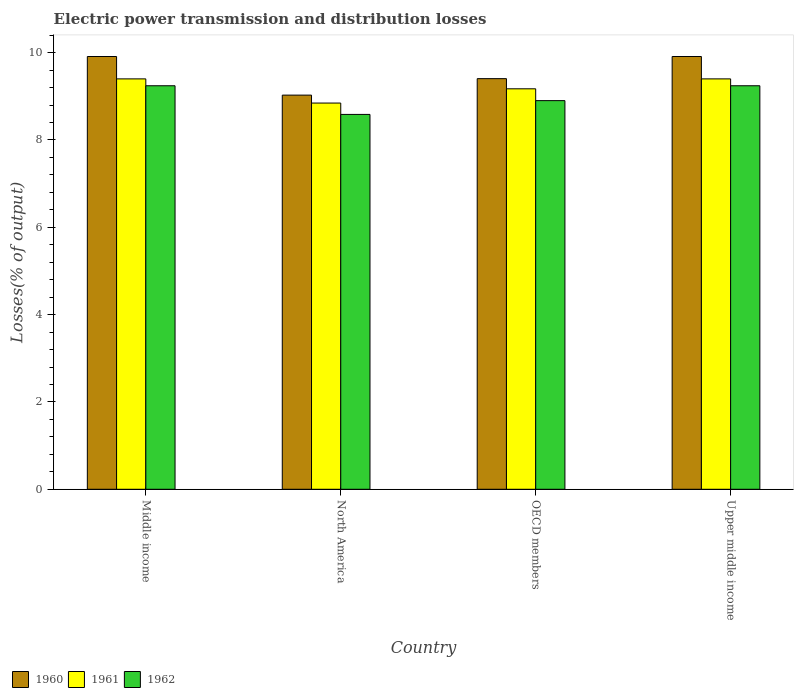How many different coloured bars are there?
Provide a short and direct response. 3. Are the number of bars per tick equal to the number of legend labels?
Make the answer very short. Yes. How many bars are there on the 2nd tick from the right?
Provide a succinct answer. 3. What is the label of the 2nd group of bars from the left?
Give a very brief answer. North America. What is the electric power transmission and distribution losses in 1962 in North America?
Give a very brief answer. 8.59. Across all countries, what is the maximum electric power transmission and distribution losses in 1962?
Your answer should be compact. 9.24. Across all countries, what is the minimum electric power transmission and distribution losses in 1961?
Your response must be concise. 8.85. What is the total electric power transmission and distribution losses in 1962 in the graph?
Keep it short and to the point. 35.97. What is the difference between the electric power transmission and distribution losses in 1961 in North America and that in Upper middle income?
Keep it short and to the point. -0.55. What is the difference between the electric power transmission and distribution losses in 1960 in North America and the electric power transmission and distribution losses in 1962 in Middle income?
Provide a short and direct response. -0.21. What is the average electric power transmission and distribution losses in 1962 per country?
Offer a terse response. 8.99. What is the difference between the electric power transmission and distribution losses of/in 1961 and electric power transmission and distribution losses of/in 1960 in Upper middle income?
Your answer should be very brief. -0.51. In how many countries, is the electric power transmission and distribution losses in 1960 greater than 7.2 %?
Provide a short and direct response. 4. What is the ratio of the electric power transmission and distribution losses in 1962 in OECD members to that in Upper middle income?
Offer a very short reply. 0.96. What is the difference between the highest and the second highest electric power transmission and distribution losses in 1961?
Your answer should be very brief. 0.23. What is the difference between the highest and the lowest electric power transmission and distribution losses in 1962?
Your response must be concise. 0.66. In how many countries, is the electric power transmission and distribution losses in 1962 greater than the average electric power transmission and distribution losses in 1962 taken over all countries?
Your answer should be compact. 2. What does the 1st bar from the right in Upper middle income represents?
Your answer should be very brief. 1962. How many countries are there in the graph?
Your answer should be very brief. 4. What is the difference between two consecutive major ticks on the Y-axis?
Offer a terse response. 2. Does the graph contain any zero values?
Your answer should be compact. No. Where does the legend appear in the graph?
Offer a terse response. Bottom left. How many legend labels are there?
Make the answer very short. 3. What is the title of the graph?
Your response must be concise. Electric power transmission and distribution losses. What is the label or title of the Y-axis?
Ensure brevity in your answer.  Losses(% of output). What is the Losses(% of output) in 1960 in Middle income?
Give a very brief answer. 9.91. What is the Losses(% of output) of 1961 in Middle income?
Provide a succinct answer. 9.4. What is the Losses(% of output) in 1962 in Middle income?
Your response must be concise. 9.24. What is the Losses(% of output) in 1960 in North America?
Provide a short and direct response. 9.03. What is the Losses(% of output) in 1961 in North America?
Your response must be concise. 8.85. What is the Losses(% of output) of 1962 in North America?
Give a very brief answer. 8.59. What is the Losses(% of output) in 1960 in OECD members?
Provide a succinct answer. 9.4. What is the Losses(% of output) of 1961 in OECD members?
Keep it short and to the point. 9.17. What is the Losses(% of output) in 1962 in OECD members?
Make the answer very short. 8.9. What is the Losses(% of output) of 1960 in Upper middle income?
Your answer should be compact. 9.91. What is the Losses(% of output) in 1961 in Upper middle income?
Your answer should be compact. 9.4. What is the Losses(% of output) in 1962 in Upper middle income?
Make the answer very short. 9.24. Across all countries, what is the maximum Losses(% of output) of 1960?
Give a very brief answer. 9.91. Across all countries, what is the maximum Losses(% of output) in 1961?
Ensure brevity in your answer.  9.4. Across all countries, what is the maximum Losses(% of output) of 1962?
Your answer should be very brief. 9.24. Across all countries, what is the minimum Losses(% of output) in 1960?
Ensure brevity in your answer.  9.03. Across all countries, what is the minimum Losses(% of output) in 1961?
Give a very brief answer. 8.85. Across all countries, what is the minimum Losses(% of output) of 1962?
Your answer should be compact. 8.59. What is the total Losses(% of output) of 1960 in the graph?
Your answer should be compact. 38.25. What is the total Losses(% of output) of 1961 in the graph?
Provide a short and direct response. 36.81. What is the total Losses(% of output) of 1962 in the graph?
Ensure brevity in your answer.  35.97. What is the difference between the Losses(% of output) of 1960 in Middle income and that in North America?
Make the answer very short. 0.88. What is the difference between the Losses(% of output) of 1961 in Middle income and that in North America?
Ensure brevity in your answer.  0.55. What is the difference between the Losses(% of output) of 1962 in Middle income and that in North America?
Make the answer very short. 0.66. What is the difference between the Losses(% of output) of 1960 in Middle income and that in OECD members?
Keep it short and to the point. 0.51. What is the difference between the Losses(% of output) of 1961 in Middle income and that in OECD members?
Provide a short and direct response. 0.23. What is the difference between the Losses(% of output) of 1962 in Middle income and that in OECD members?
Provide a succinct answer. 0.34. What is the difference between the Losses(% of output) of 1961 in Middle income and that in Upper middle income?
Provide a succinct answer. 0. What is the difference between the Losses(% of output) in 1960 in North America and that in OECD members?
Ensure brevity in your answer.  -0.38. What is the difference between the Losses(% of output) of 1961 in North America and that in OECD members?
Your response must be concise. -0.33. What is the difference between the Losses(% of output) of 1962 in North America and that in OECD members?
Keep it short and to the point. -0.32. What is the difference between the Losses(% of output) of 1960 in North America and that in Upper middle income?
Ensure brevity in your answer.  -0.88. What is the difference between the Losses(% of output) in 1961 in North America and that in Upper middle income?
Your response must be concise. -0.55. What is the difference between the Losses(% of output) of 1962 in North America and that in Upper middle income?
Provide a short and direct response. -0.66. What is the difference between the Losses(% of output) of 1960 in OECD members and that in Upper middle income?
Make the answer very short. -0.51. What is the difference between the Losses(% of output) in 1961 in OECD members and that in Upper middle income?
Offer a very short reply. -0.23. What is the difference between the Losses(% of output) of 1962 in OECD members and that in Upper middle income?
Provide a succinct answer. -0.34. What is the difference between the Losses(% of output) in 1960 in Middle income and the Losses(% of output) in 1961 in North America?
Offer a terse response. 1.07. What is the difference between the Losses(% of output) of 1960 in Middle income and the Losses(% of output) of 1962 in North America?
Ensure brevity in your answer.  1.33. What is the difference between the Losses(% of output) in 1961 in Middle income and the Losses(% of output) in 1962 in North America?
Ensure brevity in your answer.  0.81. What is the difference between the Losses(% of output) in 1960 in Middle income and the Losses(% of output) in 1961 in OECD members?
Provide a short and direct response. 0.74. What is the difference between the Losses(% of output) in 1960 in Middle income and the Losses(% of output) in 1962 in OECD members?
Offer a terse response. 1.01. What is the difference between the Losses(% of output) in 1961 in Middle income and the Losses(% of output) in 1962 in OECD members?
Provide a short and direct response. 0.5. What is the difference between the Losses(% of output) of 1960 in Middle income and the Losses(% of output) of 1961 in Upper middle income?
Give a very brief answer. 0.51. What is the difference between the Losses(% of output) in 1960 in Middle income and the Losses(% of output) in 1962 in Upper middle income?
Your response must be concise. 0.67. What is the difference between the Losses(% of output) of 1961 in Middle income and the Losses(% of output) of 1962 in Upper middle income?
Provide a short and direct response. 0.16. What is the difference between the Losses(% of output) of 1960 in North America and the Losses(% of output) of 1961 in OECD members?
Make the answer very short. -0.14. What is the difference between the Losses(% of output) in 1960 in North America and the Losses(% of output) in 1962 in OECD members?
Your answer should be compact. 0.13. What is the difference between the Losses(% of output) in 1961 in North America and the Losses(% of output) in 1962 in OECD members?
Give a very brief answer. -0.06. What is the difference between the Losses(% of output) in 1960 in North America and the Losses(% of output) in 1961 in Upper middle income?
Your answer should be compact. -0.37. What is the difference between the Losses(% of output) in 1960 in North America and the Losses(% of output) in 1962 in Upper middle income?
Your answer should be compact. -0.21. What is the difference between the Losses(% of output) in 1961 in North America and the Losses(% of output) in 1962 in Upper middle income?
Provide a short and direct response. -0.4. What is the difference between the Losses(% of output) of 1960 in OECD members and the Losses(% of output) of 1961 in Upper middle income?
Keep it short and to the point. 0.01. What is the difference between the Losses(% of output) of 1960 in OECD members and the Losses(% of output) of 1962 in Upper middle income?
Provide a succinct answer. 0.16. What is the difference between the Losses(% of output) in 1961 in OECD members and the Losses(% of output) in 1962 in Upper middle income?
Ensure brevity in your answer.  -0.07. What is the average Losses(% of output) of 1960 per country?
Give a very brief answer. 9.56. What is the average Losses(% of output) in 1961 per country?
Provide a short and direct response. 9.2. What is the average Losses(% of output) in 1962 per country?
Provide a short and direct response. 8.99. What is the difference between the Losses(% of output) of 1960 and Losses(% of output) of 1961 in Middle income?
Give a very brief answer. 0.51. What is the difference between the Losses(% of output) of 1960 and Losses(% of output) of 1962 in Middle income?
Provide a short and direct response. 0.67. What is the difference between the Losses(% of output) in 1961 and Losses(% of output) in 1962 in Middle income?
Offer a very short reply. 0.16. What is the difference between the Losses(% of output) of 1960 and Losses(% of output) of 1961 in North America?
Provide a short and direct response. 0.18. What is the difference between the Losses(% of output) in 1960 and Losses(% of output) in 1962 in North America?
Make the answer very short. 0.44. What is the difference between the Losses(% of output) in 1961 and Losses(% of output) in 1962 in North America?
Your answer should be compact. 0.26. What is the difference between the Losses(% of output) in 1960 and Losses(% of output) in 1961 in OECD members?
Make the answer very short. 0.23. What is the difference between the Losses(% of output) in 1960 and Losses(% of output) in 1962 in OECD members?
Keep it short and to the point. 0.5. What is the difference between the Losses(% of output) in 1961 and Losses(% of output) in 1962 in OECD members?
Your answer should be very brief. 0.27. What is the difference between the Losses(% of output) in 1960 and Losses(% of output) in 1961 in Upper middle income?
Ensure brevity in your answer.  0.51. What is the difference between the Losses(% of output) of 1960 and Losses(% of output) of 1962 in Upper middle income?
Offer a very short reply. 0.67. What is the difference between the Losses(% of output) in 1961 and Losses(% of output) in 1962 in Upper middle income?
Make the answer very short. 0.16. What is the ratio of the Losses(% of output) in 1960 in Middle income to that in North America?
Give a very brief answer. 1.1. What is the ratio of the Losses(% of output) in 1961 in Middle income to that in North America?
Make the answer very short. 1.06. What is the ratio of the Losses(% of output) in 1962 in Middle income to that in North America?
Provide a succinct answer. 1.08. What is the ratio of the Losses(% of output) in 1960 in Middle income to that in OECD members?
Your answer should be compact. 1.05. What is the ratio of the Losses(% of output) of 1961 in Middle income to that in OECD members?
Your response must be concise. 1.02. What is the ratio of the Losses(% of output) in 1962 in Middle income to that in OECD members?
Your answer should be compact. 1.04. What is the ratio of the Losses(% of output) in 1961 in Middle income to that in Upper middle income?
Your response must be concise. 1. What is the ratio of the Losses(% of output) of 1962 in Middle income to that in Upper middle income?
Give a very brief answer. 1. What is the ratio of the Losses(% of output) in 1960 in North America to that in OECD members?
Offer a terse response. 0.96. What is the ratio of the Losses(% of output) of 1961 in North America to that in OECD members?
Your answer should be very brief. 0.96. What is the ratio of the Losses(% of output) in 1962 in North America to that in OECD members?
Offer a very short reply. 0.96. What is the ratio of the Losses(% of output) in 1960 in North America to that in Upper middle income?
Offer a terse response. 0.91. What is the ratio of the Losses(% of output) of 1961 in North America to that in Upper middle income?
Provide a short and direct response. 0.94. What is the ratio of the Losses(% of output) of 1962 in North America to that in Upper middle income?
Your answer should be compact. 0.93. What is the ratio of the Losses(% of output) of 1960 in OECD members to that in Upper middle income?
Give a very brief answer. 0.95. What is the ratio of the Losses(% of output) in 1961 in OECD members to that in Upper middle income?
Provide a succinct answer. 0.98. What is the ratio of the Losses(% of output) of 1962 in OECD members to that in Upper middle income?
Provide a short and direct response. 0.96. What is the difference between the highest and the second highest Losses(% of output) in 1961?
Your answer should be compact. 0. What is the difference between the highest and the lowest Losses(% of output) of 1960?
Offer a very short reply. 0.88. What is the difference between the highest and the lowest Losses(% of output) in 1961?
Make the answer very short. 0.55. What is the difference between the highest and the lowest Losses(% of output) in 1962?
Make the answer very short. 0.66. 